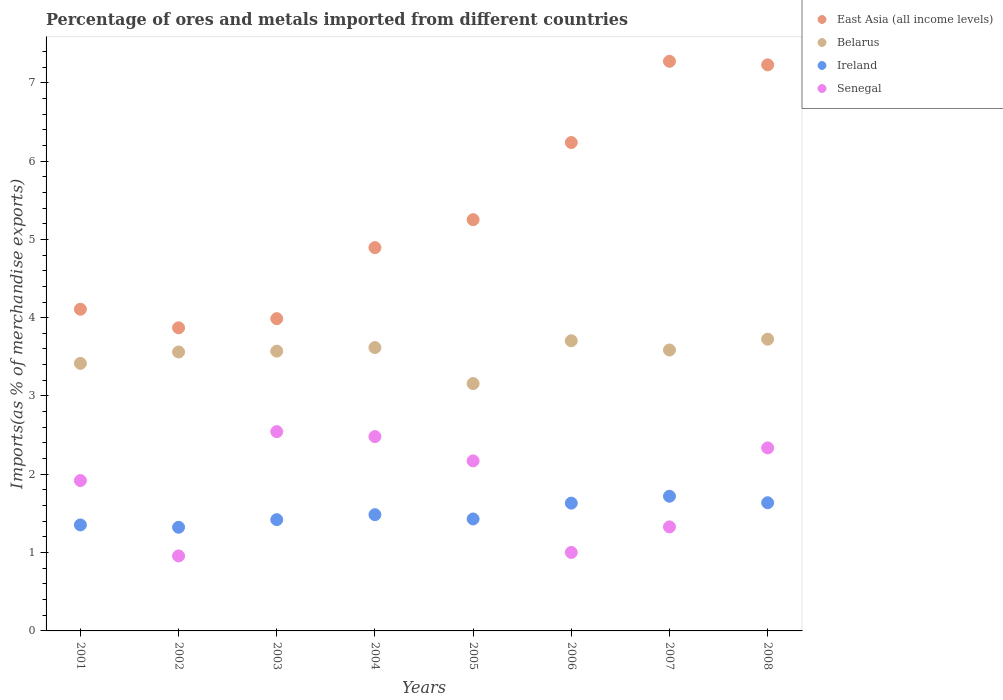How many different coloured dotlines are there?
Ensure brevity in your answer.  4. Is the number of dotlines equal to the number of legend labels?
Offer a very short reply. Yes. What is the percentage of imports to different countries in Senegal in 2007?
Your answer should be compact. 1.33. Across all years, what is the maximum percentage of imports to different countries in Ireland?
Your response must be concise. 1.72. Across all years, what is the minimum percentage of imports to different countries in Senegal?
Make the answer very short. 0.96. In which year was the percentage of imports to different countries in East Asia (all income levels) maximum?
Provide a succinct answer. 2007. What is the total percentage of imports to different countries in East Asia (all income levels) in the graph?
Offer a very short reply. 42.85. What is the difference between the percentage of imports to different countries in Ireland in 2001 and that in 2004?
Give a very brief answer. -0.13. What is the difference between the percentage of imports to different countries in Belarus in 2007 and the percentage of imports to different countries in East Asia (all income levels) in 2008?
Provide a short and direct response. -3.64. What is the average percentage of imports to different countries in Belarus per year?
Give a very brief answer. 3.54. In the year 2006, what is the difference between the percentage of imports to different countries in Ireland and percentage of imports to different countries in Belarus?
Provide a short and direct response. -2.07. What is the ratio of the percentage of imports to different countries in Senegal in 2004 to that in 2008?
Your answer should be compact. 1.06. What is the difference between the highest and the second highest percentage of imports to different countries in Ireland?
Your answer should be compact. 0.08. What is the difference between the highest and the lowest percentage of imports to different countries in Belarus?
Your answer should be compact. 0.57. In how many years, is the percentage of imports to different countries in Senegal greater than the average percentage of imports to different countries in Senegal taken over all years?
Your answer should be very brief. 5. Is it the case that in every year, the sum of the percentage of imports to different countries in East Asia (all income levels) and percentage of imports to different countries in Senegal  is greater than the sum of percentage of imports to different countries in Belarus and percentage of imports to different countries in Ireland?
Keep it short and to the point. No. Does the percentage of imports to different countries in Ireland monotonically increase over the years?
Provide a succinct answer. No. How many years are there in the graph?
Your answer should be very brief. 8. What is the difference between two consecutive major ticks on the Y-axis?
Provide a succinct answer. 1. Are the values on the major ticks of Y-axis written in scientific E-notation?
Your response must be concise. No. Does the graph contain grids?
Keep it short and to the point. No. How many legend labels are there?
Make the answer very short. 4. How are the legend labels stacked?
Your answer should be very brief. Vertical. What is the title of the graph?
Provide a short and direct response. Percentage of ores and metals imported from different countries. What is the label or title of the Y-axis?
Your answer should be compact. Imports(as % of merchandise exports). What is the Imports(as % of merchandise exports) of East Asia (all income levels) in 2001?
Your answer should be compact. 4.11. What is the Imports(as % of merchandise exports) of Belarus in 2001?
Offer a terse response. 3.42. What is the Imports(as % of merchandise exports) of Ireland in 2001?
Keep it short and to the point. 1.35. What is the Imports(as % of merchandise exports) of Senegal in 2001?
Give a very brief answer. 1.92. What is the Imports(as % of merchandise exports) in East Asia (all income levels) in 2002?
Your answer should be compact. 3.87. What is the Imports(as % of merchandise exports) in Belarus in 2002?
Provide a short and direct response. 3.56. What is the Imports(as % of merchandise exports) of Ireland in 2002?
Provide a succinct answer. 1.32. What is the Imports(as % of merchandise exports) of Senegal in 2002?
Your response must be concise. 0.96. What is the Imports(as % of merchandise exports) of East Asia (all income levels) in 2003?
Keep it short and to the point. 3.99. What is the Imports(as % of merchandise exports) of Belarus in 2003?
Provide a short and direct response. 3.57. What is the Imports(as % of merchandise exports) of Ireland in 2003?
Provide a short and direct response. 1.42. What is the Imports(as % of merchandise exports) of Senegal in 2003?
Your answer should be very brief. 2.54. What is the Imports(as % of merchandise exports) of East Asia (all income levels) in 2004?
Your answer should be very brief. 4.89. What is the Imports(as % of merchandise exports) of Belarus in 2004?
Offer a terse response. 3.62. What is the Imports(as % of merchandise exports) in Ireland in 2004?
Offer a very short reply. 1.48. What is the Imports(as % of merchandise exports) in Senegal in 2004?
Provide a succinct answer. 2.48. What is the Imports(as % of merchandise exports) in East Asia (all income levels) in 2005?
Your answer should be compact. 5.25. What is the Imports(as % of merchandise exports) in Belarus in 2005?
Give a very brief answer. 3.16. What is the Imports(as % of merchandise exports) in Ireland in 2005?
Offer a very short reply. 1.43. What is the Imports(as % of merchandise exports) in Senegal in 2005?
Your answer should be compact. 2.17. What is the Imports(as % of merchandise exports) in East Asia (all income levels) in 2006?
Offer a very short reply. 6.24. What is the Imports(as % of merchandise exports) in Belarus in 2006?
Ensure brevity in your answer.  3.71. What is the Imports(as % of merchandise exports) of Ireland in 2006?
Ensure brevity in your answer.  1.63. What is the Imports(as % of merchandise exports) of Senegal in 2006?
Your answer should be compact. 1. What is the Imports(as % of merchandise exports) in East Asia (all income levels) in 2007?
Your response must be concise. 7.27. What is the Imports(as % of merchandise exports) in Belarus in 2007?
Provide a short and direct response. 3.59. What is the Imports(as % of merchandise exports) of Ireland in 2007?
Your answer should be very brief. 1.72. What is the Imports(as % of merchandise exports) of Senegal in 2007?
Ensure brevity in your answer.  1.33. What is the Imports(as % of merchandise exports) in East Asia (all income levels) in 2008?
Your response must be concise. 7.23. What is the Imports(as % of merchandise exports) of Belarus in 2008?
Make the answer very short. 3.73. What is the Imports(as % of merchandise exports) of Ireland in 2008?
Your answer should be very brief. 1.64. What is the Imports(as % of merchandise exports) of Senegal in 2008?
Provide a short and direct response. 2.34. Across all years, what is the maximum Imports(as % of merchandise exports) in East Asia (all income levels)?
Provide a succinct answer. 7.27. Across all years, what is the maximum Imports(as % of merchandise exports) of Belarus?
Give a very brief answer. 3.73. Across all years, what is the maximum Imports(as % of merchandise exports) in Ireland?
Give a very brief answer. 1.72. Across all years, what is the maximum Imports(as % of merchandise exports) in Senegal?
Ensure brevity in your answer.  2.54. Across all years, what is the minimum Imports(as % of merchandise exports) of East Asia (all income levels)?
Make the answer very short. 3.87. Across all years, what is the minimum Imports(as % of merchandise exports) in Belarus?
Offer a very short reply. 3.16. Across all years, what is the minimum Imports(as % of merchandise exports) in Ireland?
Provide a short and direct response. 1.32. Across all years, what is the minimum Imports(as % of merchandise exports) of Senegal?
Your answer should be compact. 0.96. What is the total Imports(as % of merchandise exports) in East Asia (all income levels) in the graph?
Ensure brevity in your answer.  42.85. What is the total Imports(as % of merchandise exports) of Belarus in the graph?
Keep it short and to the point. 28.34. What is the total Imports(as % of merchandise exports) in Ireland in the graph?
Offer a very short reply. 12. What is the total Imports(as % of merchandise exports) of Senegal in the graph?
Your response must be concise. 14.74. What is the difference between the Imports(as % of merchandise exports) of East Asia (all income levels) in 2001 and that in 2002?
Give a very brief answer. 0.24. What is the difference between the Imports(as % of merchandise exports) of Belarus in 2001 and that in 2002?
Give a very brief answer. -0.15. What is the difference between the Imports(as % of merchandise exports) of Ireland in 2001 and that in 2002?
Keep it short and to the point. 0.03. What is the difference between the Imports(as % of merchandise exports) in Senegal in 2001 and that in 2002?
Your answer should be very brief. 0.96. What is the difference between the Imports(as % of merchandise exports) in East Asia (all income levels) in 2001 and that in 2003?
Keep it short and to the point. 0.12. What is the difference between the Imports(as % of merchandise exports) in Belarus in 2001 and that in 2003?
Offer a terse response. -0.16. What is the difference between the Imports(as % of merchandise exports) of Ireland in 2001 and that in 2003?
Provide a short and direct response. -0.07. What is the difference between the Imports(as % of merchandise exports) of Senegal in 2001 and that in 2003?
Offer a terse response. -0.62. What is the difference between the Imports(as % of merchandise exports) in East Asia (all income levels) in 2001 and that in 2004?
Offer a terse response. -0.79. What is the difference between the Imports(as % of merchandise exports) in Belarus in 2001 and that in 2004?
Give a very brief answer. -0.2. What is the difference between the Imports(as % of merchandise exports) in Ireland in 2001 and that in 2004?
Your answer should be compact. -0.13. What is the difference between the Imports(as % of merchandise exports) in Senegal in 2001 and that in 2004?
Keep it short and to the point. -0.56. What is the difference between the Imports(as % of merchandise exports) of East Asia (all income levels) in 2001 and that in 2005?
Keep it short and to the point. -1.14. What is the difference between the Imports(as % of merchandise exports) of Belarus in 2001 and that in 2005?
Your answer should be compact. 0.26. What is the difference between the Imports(as % of merchandise exports) in Ireland in 2001 and that in 2005?
Provide a succinct answer. -0.08. What is the difference between the Imports(as % of merchandise exports) of Senegal in 2001 and that in 2005?
Ensure brevity in your answer.  -0.25. What is the difference between the Imports(as % of merchandise exports) in East Asia (all income levels) in 2001 and that in 2006?
Make the answer very short. -2.13. What is the difference between the Imports(as % of merchandise exports) of Belarus in 2001 and that in 2006?
Ensure brevity in your answer.  -0.29. What is the difference between the Imports(as % of merchandise exports) of Ireland in 2001 and that in 2006?
Make the answer very short. -0.28. What is the difference between the Imports(as % of merchandise exports) in Senegal in 2001 and that in 2006?
Ensure brevity in your answer.  0.92. What is the difference between the Imports(as % of merchandise exports) of East Asia (all income levels) in 2001 and that in 2007?
Keep it short and to the point. -3.17. What is the difference between the Imports(as % of merchandise exports) of Belarus in 2001 and that in 2007?
Keep it short and to the point. -0.17. What is the difference between the Imports(as % of merchandise exports) of Ireland in 2001 and that in 2007?
Keep it short and to the point. -0.37. What is the difference between the Imports(as % of merchandise exports) in Senegal in 2001 and that in 2007?
Your response must be concise. 0.59. What is the difference between the Imports(as % of merchandise exports) in East Asia (all income levels) in 2001 and that in 2008?
Provide a short and direct response. -3.12. What is the difference between the Imports(as % of merchandise exports) in Belarus in 2001 and that in 2008?
Provide a succinct answer. -0.31. What is the difference between the Imports(as % of merchandise exports) in Ireland in 2001 and that in 2008?
Your response must be concise. -0.28. What is the difference between the Imports(as % of merchandise exports) in Senegal in 2001 and that in 2008?
Provide a succinct answer. -0.42. What is the difference between the Imports(as % of merchandise exports) of East Asia (all income levels) in 2002 and that in 2003?
Make the answer very short. -0.12. What is the difference between the Imports(as % of merchandise exports) in Belarus in 2002 and that in 2003?
Offer a very short reply. -0.01. What is the difference between the Imports(as % of merchandise exports) of Ireland in 2002 and that in 2003?
Provide a short and direct response. -0.1. What is the difference between the Imports(as % of merchandise exports) of Senegal in 2002 and that in 2003?
Offer a terse response. -1.59. What is the difference between the Imports(as % of merchandise exports) of East Asia (all income levels) in 2002 and that in 2004?
Your answer should be compact. -1.02. What is the difference between the Imports(as % of merchandise exports) in Belarus in 2002 and that in 2004?
Provide a succinct answer. -0.06. What is the difference between the Imports(as % of merchandise exports) in Ireland in 2002 and that in 2004?
Your response must be concise. -0.16. What is the difference between the Imports(as % of merchandise exports) of Senegal in 2002 and that in 2004?
Your answer should be very brief. -1.52. What is the difference between the Imports(as % of merchandise exports) of East Asia (all income levels) in 2002 and that in 2005?
Your answer should be compact. -1.38. What is the difference between the Imports(as % of merchandise exports) of Belarus in 2002 and that in 2005?
Provide a short and direct response. 0.4. What is the difference between the Imports(as % of merchandise exports) of Ireland in 2002 and that in 2005?
Your answer should be very brief. -0.11. What is the difference between the Imports(as % of merchandise exports) in Senegal in 2002 and that in 2005?
Provide a short and direct response. -1.21. What is the difference between the Imports(as % of merchandise exports) in East Asia (all income levels) in 2002 and that in 2006?
Offer a very short reply. -2.37. What is the difference between the Imports(as % of merchandise exports) in Belarus in 2002 and that in 2006?
Provide a succinct answer. -0.14. What is the difference between the Imports(as % of merchandise exports) in Ireland in 2002 and that in 2006?
Your answer should be very brief. -0.31. What is the difference between the Imports(as % of merchandise exports) of Senegal in 2002 and that in 2006?
Offer a very short reply. -0.04. What is the difference between the Imports(as % of merchandise exports) in East Asia (all income levels) in 2002 and that in 2007?
Offer a terse response. -3.4. What is the difference between the Imports(as % of merchandise exports) of Belarus in 2002 and that in 2007?
Your answer should be very brief. -0.03. What is the difference between the Imports(as % of merchandise exports) of Ireland in 2002 and that in 2007?
Offer a terse response. -0.4. What is the difference between the Imports(as % of merchandise exports) of Senegal in 2002 and that in 2007?
Keep it short and to the point. -0.37. What is the difference between the Imports(as % of merchandise exports) in East Asia (all income levels) in 2002 and that in 2008?
Offer a very short reply. -3.36. What is the difference between the Imports(as % of merchandise exports) in Belarus in 2002 and that in 2008?
Provide a succinct answer. -0.16. What is the difference between the Imports(as % of merchandise exports) in Ireland in 2002 and that in 2008?
Provide a short and direct response. -0.31. What is the difference between the Imports(as % of merchandise exports) in Senegal in 2002 and that in 2008?
Offer a terse response. -1.38. What is the difference between the Imports(as % of merchandise exports) of East Asia (all income levels) in 2003 and that in 2004?
Offer a very short reply. -0.91. What is the difference between the Imports(as % of merchandise exports) in Belarus in 2003 and that in 2004?
Offer a very short reply. -0.05. What is the difference between the Imports(as % of merchandise exports) of Ireland in 2003 and that in 2004?
Make the answer very short. -0.06. What is the difference between the Imports(as % of merchandise exports) in Senegal in 2003 and that in 2004?
Ensure brevity in your answer.  0.06. What is the difference between the Imports(as % of merchandise exports) of East Asia (all income levels) in 2003 and that in 2005?
Make the answer very short. -1.26. What is the difference between the Imports(as % of merchandise exports) in Belarus in 2003 and that in 2005?
Provide a short and direct response. 0.41. What is the difference between the Imports(as % of merchandise exports) in Ireland in 2003 and that in 2005?
Your answer should be very brief. -0.01. What is the difference between the Imports(as % of merchandise exports) in Senegal in 2003 and that in 2005?
Provide a short and direct response. 0.37. What is the difference between the Imports(as % of merchandise exports) of East Asia (all income levels) in 2003 and that in 2006?
Provide a short and direct response. -2.25. What is the difference between the Imports(as % of merchandise exports) in Belarus in 2003 and that in 2006?
Offer a terse response. -0.13. What is the difference between the Imports(as % of merchandise exports) of Ireland in 2003 and that in 2006?
Your answer should be compact. -0.21. What is the difference between the Imports(as % of merchandise exports) in Senegal in 2003 and that in 2006?
Keep it short and to the point. 1.54. What is the difference between the Imports(as % of merchandise exports) of East Asia (all income levels) in 2003 and that in 2007?
Your answer should be compact. -3.29. What is the difference between the Imports(as % of merchandise exports) of Belarus in 2003 and that in 2007?
Provide a short and direct response. -0.01. What is the difference between the Imports(as % of merchandise exports) of Ireland in 2003 and that in 2007?
Provide a short and direct response. -0.3. What is the difference between the Imports(as % of merchandise exports) in Senegal in 2003 and that in 2007?
Ensure brevity in your answer.  1.22. What is the difference between the Imports(as % of merchandise exports) in East Asia (all income levels) in 2003 and that in 2008?
Offer a terse response. -3.24. What is the difference between the Imports(as % of merchandise exports) of Belarus in 2003 and that in 2008?
Offer a very short reply. -0.15. What is the difference between the Imports(as % of merchandise exports) in Ireland in 2003 and that in 2008?
Your answer should be compact. -0.22. What is the difference between the Imports(as % of merchandise exports) of Senegal in 2003 and that in 2008?
Make the answer very short. 0.21. What is the difference between the Imports(as % of merchandise exports) of East Asia (all income levels) in 2004 and that in 2005?
Give a very brief answer. -0.36. What is the difference between the Imports(as % of merchandise exports) in Belarus in 2004 and that in 2005?
Provide a short and direct response. 0.46. What is the difference between the Imports(as % of merchandise exports) of Ireland in 2004 and that in 2005?
Keep it short and to the point. 0.05. What is the difference between the Imports(as % of merchandise exports) of Senegal in 2004 and that in 2005?
Offer a very short reply. 0.31. What is the difference between the Imports(as % of merchandise exports) in East Asia (all income levels) in 2004 and that in 2006?
Offer a very short reply. -1.34. What is the difference between the Imports(as % of merchandise exports) in Belarus in 2004 and that in 2006?
Your response must be concise. -0.09. What is the difference between the Imports(as % of merchandise exports) in Ireland in 2004 and that in 2006?
Your response must be concise. -0.15. What is the difference between the Imports(as % of merchandise exports) of Senegal in 2004 and that in 2006?
Make the answer very short. 1.48. What is the difference between the Imports(as % of merchandise exports) in East Asia (all income levels) in 2004 and that in 2007?
Keep it short and to the point. -2.38. What is the difference between the Imports(as % of merchandise exports) in Belarus in 2004 and that in 2007?
Give a very brief answer. 0.03. What is the difference between the Imports(as % of merchandise exports) of Ireland in 2004 and that in 2007?
Provide a succinct answer. -0.24. What is the difference between the Imports(as % of merchandise exports) in Senegal in 2004 and that in 2007?
Make the answer very short. 1.15. What is the difference between the Imports(as % of merchandise exports) in East Asia (all income levels) in 2004 and that in 2008?
Make the answer very short. -2.33. What is the difference between the Imports(as % of merchandise exports) of Belarus in 2004 and that in 2008?
Provide a succinct answer. -0.11. What is the difference between the Imports(as % of merchandise exports) of Ireland in 2004 and that in 2008?
Your response must be concise. -0.15. What is the difference between the Imports(as % of merchandise exports) of Senegal in 2004 and that in 2008?
Offer a very short reply. 0.14. What is the difference between the Imports(as % of merchandise exports) of East Asia (all income levels) in 2005 and that in 2006?
Provide a short and direct response. -0.99. What is the difference between the Imports(as % of merchandise exports) of Belarus in 2005 and that in 2006?
Ensure brevity in your answer.  -0.55. What is the difference between the Imports(as % of merchandise exports) in Ireland in 2005 and that in 2006?
Your response must be concise. -0.2. What is the difference between the Imports(as % of merchandise exports) in Senegal in 2005 and that in 2006?
Keep it short and to the point. 1.17. What is the difference between the Imports(as % of merchandise exports) of East Asia (all income levels) in 2005 and that in 2007?
Provide a short and direct response. -2.02. What is the difference between the Imports(as % of merchandise exports) of Belarus in 2005 and that in 2007?
Give a very brief answer. -0.43. What is the difference between the Imports(as % of merchandise exports) in Ireland in 2005 and that in 2007?
Keep it short and to the point. -0.29. What is the difference between the Imports(as % of merchandise exports) of Senegal in 2005 and that in 2007?
Ensure brevity in your answer.  0.84. What is the difference between the Imports(as % of merchandise exports) in East Asia (all income levels) in 2005 and that in 2008?
Keep it short and to the point. -1.98. What is the difference between the Imports(as % of merchandise exports) of Belarus in 2005 and that in 2008?
Make the answer very short. -0.57. What is the difference between the Imports(as % of merchandise exports) in Ireland in 2005 and that in 2008?
Offer a terse response. -0.21. What is the difference between the Imports(as % of merchandise exports) in Senegal in 2005 and that in 2008?
Provide a succinct answer. -0.17. What is the difference between the Imports(as % of merchandise exports) of East Asia (all income levels) in 2006 and that in 2007?
Ensure brevity in your answer.  -1.04. What is the difference between the Imports(as % of merchandise exports) of Belarus in 2006 and that in 2007?
Ensure brevity in your answer.  0.12. What is the difference between the Imports(as % of merchandise exports) of Ireland in 2006 and that in 2007?
Ensure brevity in your answer.  -0.09. What is the difference between the Imports(as % of merchandise exports) of Senegal in 2006 and that in 2007?
Your response must be concise. -0.33. What is the difference between the Imports(as % of merchandise exports) of East Asia (all income levels) in 2006 and that in 2008?
Give a very brief answer. -0.99. What is the difference between the Imports(as % of merchandise exports) of Belarus in 2006 and that in 2008?
Your response must be concise. -0.02. What is the difference between the Imports(as % of merchandise exports) of Ireland in 2006 and that in 2008?
Your answer should be compact. -0.01. What is the difference between the Imports(as % of merchandise exports) of Senegal in 2006 and that in 2008?
Make the answer very short. -1.33. What is the difference between the Imports(as % of merchandise exports) in East Asia (all income levels) in 2007 and that in 2008?
Your answer should be compact. 0.05. What is the difference between the Imports(as % of merchandise exports) of Belarus in 2007 and that in 2008?
Offer a terse response. -0.14. What is the difference between the Imports(as % of merchandise exports) in Ireland in 2007 and that in 2008?
Provide a succinct answer. 0.08. What is the difference between the Imports(as % of merchandise exports) of Senegal in 2007 and that in 2008?
Ensure brevity in your answer.  -1.01. What is the difference between the Imports(as % of merchandise exports) in East Asia (all income levels) in 2001 and the Imports(as % of merchandise exports) in Belarus in 2002?
Provide a short and direct response. 0.55. What is the difference between the Imports(as % of merchandise exports) of East Asia (all income levels) in 2001 and the Imports(as % of merchandise exports) of Ireland in 2002?
Provide a succinct answer. 2.78. What is the difference between the Imports(as % of merchandise exports) of East Asia (all income levels) in 2001 and the Imports(as % of merchandise exports) of Senegal in 2002?
Make the answer very short. 3.15. What is the difference between the Imports(as % of merchandise exports) in Belarus in 2001 and the Imports(as % of merchandise exports) in Ireland in 2002?
Offer a very short reply. 2.09. What is the difference between the Imports(as % of merchandise exports) in Belarus in 2001 and the Imports(as % of merchandise exports) in Senegal in 2002?
Ensure brevity in your answer.  2.46. What is the difference between the Imports(as % of merchandise exports) of Ireland in 2001 and the Imports(as % of merchandise exports) of Senegal in 2002?
Make the answer very short. 0.4. What is the difference between the Imports(as % of merchandise exports) in East Asia (all income levels) in 2001 and the Imports(as % of merchandise exports) in Belarus in 2003?
Ensure brevity in your answer.  0.54. What is the difference between the Imports(as % of merchandise exports) in East Asia (all income levels) in 2001 and the Imports(as % of merchandise exports) in Ireland in 2003?
Your answer should be very brief. 2.69. What is the difference between the Imports(as % of merchandise exports) in East Asia (all income levels) in 2001 and the Imports(as % of merchandise exports) in Senegal in 2003?
Your answer should be compact. 1.56. What is the difference between the Imports(as % of merchandise exports) in Belarus in 2001 and the Imports(as % of merchandise exports) in Ireland in 2003?
Your answer should be very brief. 2. What is the difference between the Imports(as % of merchandise exports) of Belarus in 2001 and the Imports(as % of merchandise exports) of Senegal in 2003?
Your response must be concise. 0.87. What is the difference between the Imports(as % of merchandise exports) of Ireland in 2001 and the Imports(as % of merchandise exports) of Senegal in 2003?
Ensure brevity in your answer.  -1.19. What is the difference between the Imports(as % of merchandise exports) in East Asia (all income levels) in 2001 and the Imports(as % of merchandise exports) in Belarus in 2004?
Your response must be concise. 0.49. What is the difference between the Imports(as % of merchandise exports) in East Asia (all income levels) in 2001 and the Imports(as % of merchandise exports) in Ireland in 2004?
Make the answer very short. 2.62. What is the difference between the Imports(as % of merchandise exports) of East Asia (all income levels) in 2001 and the Imports(as % of merchandise exports) of Senegal in 2004?
Your answer should be compact. 1.63. What is the difference between the Imports(as % of merchandise exports) of Belarus in 2001 and the Imports(as % of merchandise exports) of Ireland in 2004?
Provide a succinct answer. 1.93. What is the difference between the Imports(as % of merchandise exports) of Belarus in 2001 and the Imports(as % of merchandise exports) of Senegal in 2004?
Ensure brevity in your answer.  0.93. What is the difference between the Imports(as % of merchandise exports) of Ireland in 2001 and the Imports(as % of merchandise exports) of Senegal in 2004?
Your answer should be compact. -1.13. What is the difference between the Imports(as % of merchandise exports) in East Asia (all income levels) in 2001 and the Imports(as % of merchandise exports) in Belarus in 2005?
Offer a very short reply. 0.95. What is the difference between the Imports(as % of merchandise exports) of East Asia (all income levels) in 2001 and the Imports(as % of merchandise exports) of Ireland in 2005?
Ensure brevity in your answer.  2.68. What is the difference between the Imports(as % of merchandise exports) of East Asia (all income levels) in 2001 and the Imports(as % of merchandise exports) of Senegal in 2005?
Ensure brevity in your answer.  1.94. What is the difference between the Imports(as % of merchandise exports) of Belarus in 2001 and the Imports(as % of merchandise exports) of Ireland in 2005?
Offer a very short reply. 1.99. What is the difference between the Imports(as % of merchandise exports) of Belarus in 2001 and the Imports(as % of merchandise exports) of Senegal in 2005?
Make the answer very short. 1.25. What is the difference between the Imports(as % of merchandise exports) in Ireland in 2001 and the Imports(as % of merchandise exports) in Senegal in 2005?
Offer a very short reply. -0.82. What is the difference between the Imports(as % of merchandise exports) of East Asia (all income levels) in 2001 and the Imports(as % of merchandise exports) of Belarus in 2006?
Give a very brief answer. 0.4. What is the difference between the Imports(as % of merchandise exports) in East Asia (all income levels) in 2001 and the Imports(as % of merchandise exports) in Ireland in 2006?
Provide a short and direct response. 2.48. What is the difference between the Imports(as % of merchandise exports) in East Asia (all income levels) in 2001 and the Imports(as % of merchandise exports) in Senegal in 2006?
Your answer should be compact. 3.11. What is the difference between the Imports(as % of merchandise exports) of Belarus in 2001 and the Imports(as % of merchandise exports) of Ireland in 2006?
Your answer should be compact. 1.78. What is the difference between the Imports(as % of merchandise exports) of Belarus in 2001 and the Imports(as % of merchandise exports) of Senegal in 2006?
Ensure brevity in your answer.  2.41. What is the difference between the Imports(as % of merchandise exports) of Ireland in 2001 and the Imports(as % of merchandise exports) of Senegal in 2006?
Give a very brief answer. 0.35. What is the difference between the Imports(as % of merchandise exports) in East Asia (all income levels) in 2001 and the Imports(as % of merchandise exports) in Belarus in 2007?
Your response must be concise. 0.52. What is the difference between the Imports(as % of merchandise exports) of East Asia (all income levels) in 2001 and the Imports(as % of merchandise exports) of Ireland in 2007?
Offer a very short reply. 2.39. What is the difference between the Imports(as % of merchandise exports) in East Asia (all income levels) in 2001 and the Imports(as % of merchandise exports) in Senegal in 2007?
Give a very brief answer. 2.78. What is the difference between the Imports(as % of merchandise exports) in Belarus in 2001 and the Imports(as % of merchandise exports) in Ireland in 2007?
Offer a very short reply. 1.7. What is the difference between the Imports(as % of merchandise exports) in Belarus in 2001 and the Imports(as % of merchandise exports) in Senegal in 2007?
Provide a succinct answer. 2.09. What is the difference between the Imports(as % of merchandise exports) of Ireland in 2001 and the Imports(as % of merchandise exports) of Senegal in 2007?
Provide a short and direct response. 0.03. What is the difference between the Imports(as % of merchandise exports) in East Asia (all income levels) in 2001 and the Imports(as % of merchandise exports) in Belarus in 2008?
Provide a succinct answer. 0.38. What is the difference between the Imports(as % of merchandise exports) of East Asia (all income levels) in 2001 and the Imports(as % of merchandise exports) of Ireland in 2008?
Give a very brief answer. 2.47. What is the difference between the Imports(as % of merchandise exports) of East Asia (all income levels) in 2001 and the Imports(as % of merchandise exports) of Senegal in 2008?
Your response must be concise. 1.77. What is the difference between the Imports(as % of merchandise exports) in Belarus in 2001 and the Imports(as % of merchandise exports) in Ireland in 2008?
Your response must be concise. 1.78. What is the difference between the Imports(as % of merchandise exports) in Belarus in 2001 and the Imports(as % of merchandise exports) in Senegal in 2008?
Make the answer very short. 1.08. What is the difference between the Imports(as % of merchandise exports) in Ireland in 2001 and the Imports(as % of merchandise exports) in Senegal in 2008?
Give a very brief answer. -0.98. What is the difference between the Imports(as % of merchandise exports) of East Asia (all income levels) in 2002 and the Imports(as % of merchandise exports) of Belarus in 2003?
Give a very brief answer. 0.3. What is the difference between the Imports(as % of merchandise exports) of East Asia (all income levels) in 2002 and the Imports(as % of merchandise exports) of Ireland in 2003?
Your answer should be compact. 2.45. What is the difference between the Imports(as % of merchandise exports) of East Asia (all income levels) in 2002 and the Imports(as % of merchandise exports) of Senegal in 2003?
Keep it short and to the point. 1.33. What is the difference between the Imports(as % of merchandise exports) in Belarus in 2002 and the Imports(as % of merchandise exports) in Ireland in 2003?
Your answer should be compact. 2.14. What is the difference between the Imports(as % of merchandise exports) of Belarus in 2002 and the Imports(as % of merchandise exports) of Senegal in 2003?
Your answer should be compact. 1.02. What is the difference between the Imports(as % of merchandise exports) in Ireland in 2002 and the Imports(as % of merchandise exports) in Senegal in 2003?
Make the answer very short. -1.22. What is the difference between the Imports(as % of merchandise exports) of East Asia (all income levels) in 2002 and the Imports(as % of merchandise exports) of Belarus in 2004?
Give a very brief answer. 0.25. What is the difference between the Imports(as % of merchandise exports) of East Asia (all income levels) in 2002 and the Imports(as % of merchandise exports) of Ireland in 2004?
Make the answer very short. 2.39. What is the difference between the Imports(as % of merchandise exports) of East Asia (all income levels) in 2002 and the Imports(as % of merchandise exports) of Senegal in 2004?
Make the answer very short. 1.39. What is the difference between the Imports(as % of merchandise exports) of Belarus in 2002 and the Imports(as % of merchandise exports) of Ireland in 2004?
Ensure brevity in your answer.  2.08. What is the difference between the Imports(as % of merchandise exports) of Belarus in 2002 and the Imports(as % of merchandise exports) of Senegal in 2004?
Your answer should be compact. 1.08. What is the difference between the Imports(as % of merchandise exports) of Ireland in 2002 and the Imports(as % of merchandise exports) of Senegal in 2004?
Offer a very short reply. -1.16. What is the difference between the Imports(as % of merchandise exports) of East Asia (all income levels) in 2002 and the Imports(as % of merchandise exports) of Belarus in 2005?
Offer a very short reply. 0.71. What is the difference between the Imports(as % of merchandise exports) in East Asia (all income levels) in 2002 and the Imports(as % of merchandise exports) in Ireland in 2005?
Your answer should be compact. 2.44. What is the difference between the Imports(as % of merchandise exports) of East Asia (all income levels) in 2002 and the Imports(as % of merchandise exports) of Senegal in 2005?
Give a very brief answer. 1.7. What is the difference between the Imports(as % of merchandise exports) of Belarus in 2002 and the Imports(as % of merchandise exports) of Ireland in 2005?
Give a very brief answer. 2.13. What is the difference between the Imports(as % of merchandise exports) of Belarus in 2002 and the Imports(as % of merchandise exports) of Senegal in 2005?
Keep it short and to the point. 1.39. What is the difference between the Imports(as % of merchandise exports) in Ireland in 2002 and the Imports(as % of merchandise exports) in Senegal in 2005?
Your answer should be very brief. -0.85. What is the difference between the Imports(as % of merchandise exports) in East Asia (all income levels) in 2002 and the Imports(as % of merchandise exports) in Belarus in 2006?
Make the answer very short. 0.17. What is the difference between the Imports(as % of merchandise exports) in East Asia (all income levels) in 2002 and the Imports(as % of merchandise exports) in Ireland in 2006?
Your answer should be compact. 2.24. What is the difference between the Imports(as % of merchandise exports) of East Asia (all income levels) in 2002 and the Imports(as % of merchandise exports) of Senegal in 2006?
Your answer should be very brief. 2.87. What is the difference between the Imports(as % of merchandise exports) in Belarus in 2002 and the Imports(as % of merchandise exports) in Ireland in 2006?
Offer a terse response. 1.93. What is the difference between the Imports(as % of merchandise exports) of Belarus in 2002 and the Imports(as % of merchandise exports) of Senegal in 2006?
Give a very brief answer. 2.56. What is the difference between the Imports(as % of merchandise exports) of Ireland in 2002 and the Imports(as % of merchandise exports) of Senegal in 2006?
Provide a short and direct response. 0.32. What is the difference between the Imports(as % of merchandise exports) of East Asia (all income levels) in 2002 and the Imports(as % of merchandise exports) of Belarus in 2007?
Provide a succinct answer. 0.28. What is the difference between the Imports(as % of merchandise exports) in East Asia (all income levels) in 2002 and the Imports(as % of merchandise exports) in Ireland in 2007?
Ensure brevity in your answer.  2.15. What is the difference between the Imports(as % of merchandise exports) of East Asia (all income levels) in 2002 and the Imports(as % of merchandise exports) of Senegal in 2007?
Make the answer very short. 2.54. What is the difference between the Imports(as % of merchandise exports) in Belarus in 2002 and the Imports(as % of merchandise exports) in Ireland in 2007?
Ensure brevity in your answer.  1.84. What is the difference between the Imports(as % of merchandise exports) in Belarus in 2002 and the Imports(as % of merchandise exports) in Senegal in 2007?
Offer a terse response. 2.23. What is the difference between the Imports(as % of merchandise exports) of Ireland in 2002 and the Imports(as % of merchandise exports) of Senegal in 2007?
Offer a very short reply. -0. What is the difference between the Imports(as % of merchandise exports) in East Asia (all income levels) in 2002 and the Imports(as % of merchandise exports) in Belarus in 2008?
Ensure brevity in your answer.  0.15. What is the difference between the Imports(as % of merchandise exports) in East Asia (all income levels) in 2002 and the Imports(as % of merchandise exports) in Ireland in 2008?
Make the answer very short. 2.23. What is the difference between the Imports(as % of merchandise exports) of East Asia (all income levels) in 2002 and the Imports(as % of merchandise exports) of Senegal in 2008?
Make the answer very short. 1.53. What is the difference between the Imports(as % of merchandise exports) in Belarus in 2002 and the Imports(as % of merchandise exports) in Ireland in 2008?
Your answer should be compact. 1.92. What is the difference between the Imports(as % of merchandise exports) in Belarus in 2002 and the Imports(as % of merchandise exports) in Senegal in 2008?
Provide a short and direct response. 1.22. What is the difference between the Imports(as % of merchandise exports) in Ireland in 2002 and the Imports(as % of merchandise exports) in Senegal in 2008?
Offer a very short reply. -1.01. What is the difference between the Imports(as % of merchandise exports) of East Asia (all income levels) in 2003 and the Imports(as % of merchandise exports) of Belarus in 2004?
Your answer should be very brief. 0.37. What is the difference between the Imports(as % of merchandise exports) in East Asia (all income levels) in 2003 and the Imports(as % of merchandise exports) in Ireland in 2004?
Make the answer very short. 2.5. What is the difference between the Imports(as % of merchandise exports) in East Asia (all income levels) in 2003 and the Imports(as % of merchandise exports) in Senegal in 2004?
Your response must be concise. 1.51. What is the difference between the Imports(as % of merchandise exports) of Belarus in 2003 and the Imports(as % of merchandise exports) of Ireland in 2004?
Offer a very short reply. 2.09. What is the difference between the Imports(as % of merchandise exports) in Ireland in 2003 and the Imports(as % of merchandise exports) in Senegal in 2004?
Make the answer very short. -1.06. What is the difference between the Imports(as % of merchandise exports) of East Asia (all income levels) in 2003 and the Imports(as % of merchandise exports) of Belarus in 2005?
Give a very brief answer. 0.83. What is the difference between the Imports(as % of merchandise exports) in East Asia (all income levels) in 2003 and the Imports(as % of merchandise exports) in Ireland in 2005?
Give a very brief answer. 2.56. What is the difference between the Imports(as % of merchandise exports) in East Asia (all income levels) in 2003 and the Imports(as % of merchandise exports) in Senegal in 2005?
Your answer should be very brief. 1.82. What is the difference between the Imports(as % of merchandise exports) of Belarus in 2003 and the Imports(as % of merchandise exports) of Ireland in 2005?
Provide a succinct answer. 2.14. What is the difference between the Imports(as % of merchandise exports) of Belarus in 2003 and the Imports(as % of merchandise exports) of Senegal in 2005?
Make the answer very short. 1.4. What is the difference between the Imports(as % of merchandise exports) in Ireland in 2003 and the Imports(as % of merchandise exports) in Senegal in 2005?
Offer a very short reply. -0.75. What is the difference between the Imports(as % of merchandise exports) in East Asia (all income levels) in 2003 and the Imports(as % of merchandise exports) in Belarus in 2006?
Your response must be concise. 0.28. What is the difference between the Imports(as % of merchandise exports) in East Asia (all income levels) in 2003 and the Imports(as % of merchandise exports) in Ireland in 2006?
Provide a succinct answer. 2.36. What is the difference between the Imports(as % of merchandise exports) of East Asia (all income levels) in 2003 and the Imports(as % of merchandise exports) of Senegal in 2006?
Your answer should be compact. 2.99. What is the difference between the Imports(as % of merchandise exports) in Belarus in 2003 and the Imports(as % of merchandise exports) in Ireland in 2006?
Your answer should be very brief. 1.94. What is the difference between the Imports(as % of merchandise exports) of Belarus in 2003 and the Imports(as % of merchandise exports) of Senegal in 2006?
Give a very brief answer. 2.57. What is the difference between the Imports(as % of merchandise exports) in Ireland in 2003 and the Imports(as % of merchandise exports) in Senegal in 2006?
Give a very brief answer. 0.42. What is the difference between the Imports(as % of merchandise exports) of East Asia (all income levels) in 2003 and the Imports(as % of merchandise exports) of Belarus in 2007?
Make the answer very short. 0.4. What is the difference between the Imports(as % of merchandise exports) in East Asia (all income levels) in 2003 and the Imports(as % of merchandise exports) in Ireland in 2007?
Your answer should be compact. 2.27. What is the difference between the Imports(as % of merchandise exports) in East Asia (all income levels) in 2003 and the Imports(as % of merchandise exports) in Senegal in 2007?
Give a very brief answer. 2.66. What is the difference between the Imports(as % of merchandise exports) in Belarus in 2003 and the Imports(as % of merchandise exports) in Ireland in 2007?
Provide a short and direct response. 1.85. What is the difference between the Imports(as % of merchandise exports) of Belarus in 2003 and the Imports(as % of merchandise exports) of Senegal in 2007?
Make the answer very short. 2.24. What is the difference between the Imports(as % of merchandise exports) in Ireland in 2003 and the Imports(as % of merchandise exports) in Senegal in 2007?
Provide a succinct answer. 0.09. What is the difference between the Imports(as % of merchandise exports) of East Asia (all income levels) in 2003 and the Imports(as % of merchandise exports) of Belarus in 2008?
Your answer should be very brief. 0.26. What is the difference between the Imports(as % of merchandise exports) in East Asia (all income levels) in 2003 and the Imports(as % of merchandise exports) in Ireland in 2008?
Make the answer very short. 2.35. What is the difference between the Imports(as % of merchandise exports) in East Asia (all income levels) in 2003 and the Imports(as % of merchandise exports) in Senegal in 2008?
Your answer should be very brief. 1.65. What is the difference between the Imports(as % of merchandise exports) of Belarus in 2003 and the Imports(as % of merchandise exports) of Ireland in 2008?
Provide a short and direct response. 1.94. What is the difference between the Imports(as % of merchandise exports) in Belarus in 2003 and the Imports(as % of merchandise exports) in Senegal in 2008?
Give a very brief answer. 1.24. What is the difference between the Imports(as % of merchandise exports) in Ireland in 2003 and the Imports(as % of merchandise exports) in Senegal in 2008?
Your answer should be very brief. -0.92. What is the difference between the Imports(as % of merchandise exports) of East Asia (all income levels) in 2004 and the Imports(as % of merchandise exports) of Belarus in 2005?
Your answer should be compact. 1.74. What is the difference between the Imports(as % of merchandise exports) of East Asia (all income levels) in 2004 and the Imports(as % of merchandise exports) of Ireland in 2005?
Ensure brevity in your answer.  3.47. What is the difference between the Imports(as % of merchandise exports) of East Asia (all income levels) in 2004 and the Imports(as % of merchandise exports) of Senegal in 2005?
Offer a very short reply. 2.72. What is the difference between the Imports(as % of merchandise exports) in Belarus in 2004 and the Imports(as % of merchandise exports) in Ireland in 2005?
Offer a terse response. 2.19. What is the difference between the Imports(as % of merchandise exports) in Belarus in 2004 and the Imports(as % of merchandise exports) in Senegal in 2005?
Your answer should be very brief. 1.45. What is the difference between the Imports(as % of merchandise exports) of Ireland in 2004 and the Imports(as % of merchandise exports) of Senegal in 2005?
Offer a terse response. -0.69. What is the difference between the Imports(as % of merchandise exports) in East Asia (all income levels) in 2004 and the Imports(as % of merchandise exports) in Belarus in 2006?
Your answer should be very brief. 1.19. What is the difference between the Imports(as % of merchandise exports) in East Asia (all income levels) in 2004 and the Imports(as % of merchandise exports) in Ireland in 2006?
Your response must be concise. 3.26. What is the difference between the Imports(as % of merchandise exports) of East Asia (all income levels) in 2004 and the Imports(as % of merchandise exports) of Senegal in 2006?
Provide a succinct answer. 3.89. What is the difference between the Imports(as % of merchandise exports) in Belarus in 2004 and the Imports(as % of merchandise exports) in Ireland in 2006?
Offer a very short reply. 1.99. What is the difference between the Imports(as % of merchandise exports) of Belarus in 2004 and the Imports(as % of merchandise exports) of Senegal in 2006?
Offer a terse response. 2.62. What is the difference between the Imports(as % of merchandise exports) of Ireland in 2004 and the Imports(as % of merchandise exports) of Senegal in 2006?
Make the answer very short. 0.48. What is the difference between the Imports(as % of merchandise exports) in East Asia (all income levels) in 2004 and the Imports(as % of merchandise exports) in Belarus in 2007?
Provide a short and direct response. 1.31. What is the difference between the Imports(as % of merchandise exports) of East Asia (all income levels) in 2004 and the Imports(as % of merchandise exports) of Ireland in 2007?
Ensure brevity in your answer.  3.17. What is the difference between the Imports(as % of merchandise exports) of East Asia (all income levels) in 2004 and the Imports(as % of merchandise exports) of Senegal in 2007?
Offer a terse response. 3.57. What is the difference between the Imports(as % of merchandise exports) of Belarus in 2004 and the Imports(as % of merchandise exports) of Ireland in 2007?
Ensure brevity in your answer.  1.9. What is the difference between the Imports(as % of merchandise exports) of Belarus in 2004 and the Imports(as % of merchandise exports) of Senegal in 2007?
Keep it short and to the point. 2.29. What is the difference between the Imports(as % of merchandise exports) of Ireland in 2004 and the Imports(as % of merchandise exports) of Senegal in 2007?
Keep it short and to the point. 0.16. What is the difference between the Imports(as % of merchandise exports) in East Asia (all income levels) in 2004 and the Imports(as % of merchandise exports) in Belarus in 2008?
Your answer should be compact. 1.17. What is the difference between the Imports(as % of merchandise exports) of East Asia (all income levels) in 2004 and the Imports(as % of merchandise exports) of Ireland in 2008?
Make the answer very short. 3.26. What is the difference between the Imports(as % of merchandise exports) in East Asia (all income levels) in 2004 and the Imports(as % of merchandise exports) in Senegal in 2008?
Ensure brevity in your answer.  2.56. What is the difference between the Imports(as % of merchandise exports) in Belarus in 2004 and the Imports(as % of merchandise exports) in Ireland in 2008?
Your answer should be very brief. 1.98. What is the difference between the Imports(as % of merchandise exports) in Belarus in 2004 and the Imports(as % of merchandise exports) in Senegal in 2008?
Provide a succinct answer. 1.28. What is the difference between the Imports(as % of merchandise exports) in Ireland in 2004 and the Imports(as % of merchandise exports) in Senegal in 2008?
Provide a short and direct response. -0.85. What is the difference between the Imports(as % of merchandise exports) of East Asia (all income levels) in 2005 and the Imports(as % of merchandise exports) of Belarus in 2006?
Your answer should be compact. 1.55. What is the difference between the Imports(as % of merchandise exports) in East Asia (all income levels) in 2005 and the Imports(as % of merchandise exports) in Ireland in 2006?
Your response must be concise. 3.62. What is the difference between the Imports(as % of merchandise exports) of East Asia (all income levels) in 2005 and the Imports(as % of merchandise exports) of Senegal in 2006?
Provide a succinct answer. 4.25. What is the difference between the Imports(as % of merchandise exports) of Belarus in 2005 and the Imports(as % of merchandise exports) of Ireland in 2006?
Make the answer very short. 1.53. What is the difference between the Imports(as % of merchandise exports) of Belarus in 2005 and the Imports(as % of merchandise exports) of Senegal in 2006?
Ensure brevity in your answer.  2.16. What is the difference between the Imports(as % of merchandise exports) of Ireland in 2005 and the Imports(as % of merchandise exports) of Senegal in 2006?
Make the answer very short. 0.43. What is the difference between the Imports(as % of merchandise exports) in East Asia (all income levels) in 2005 and the Imports(as % of merchandise exports) in Belarus in 2007?
Your answer should be very brief. 1.66. What is the difference between the Imports(as % of merchandise exports) in East Asia (all income levels) in 2005 and the Imports(as % of merchandise exports) in Ireland in 2007?
Keep it short and to the point. 3.53. What is the difference between the Imports(as % of merchandise exports) of East Asia (all income levels) in 2005 and the Imports(as % of merchandise exports) of Senegal in 2007?
Make the answer very short. 3.92. What is the difference between the Imports(as % of merchandise exports) in Belarus in 2005 and the Imports(as % of merchandise exports) in Ireland in 2007?
Your answer should be compact. 1.44. What is the difference between the Imports(as % of merchandise exports) in Belarus in 2005 and the Imports(as % of merchandise exports) in Senegal in 2007?
Offer a very short reply. 1.83. What is the difference between the Imports(as % of merchandise exports) in Ireland in 2005 and the Imports(as % of merchandise exports) in Senegal in 2007?
Provide a short and direct response. 0.1. What is the difference between the Imports(as % of merchandise exports) of East Asia (all income levels) in 2005 and the Imports(as % of merchandise exports) of Belarus in 2008?
Make the answer very short. 1.53. What is the difference between the Imports(as % of merchandise exports) of East Asia (all income levels) in 2005 and the Imports(as % of merchandise exports) of Ireland in 2008?
Keep it short and to the point. 3.61. What is the difference between the Imports(as % of merchandise exports) of East Asia (all income levels) in 2005 and the Imports(as % of merchandise exports) of Senegal in 2008?
Give a very brief answer. 2.91. What is the difference between the Imports(as % of merchandise exports) of Belarus in 2005 and the Imports(as % of merchandise exports) of Ireland in 2008?
Give a very brief answer. 1.52. What is the difference between the Imports(as % of merchandise exports) of Belarus in 2005 and the Imports(as % of merchandise exports) of Senegal in 2008?
Keep it short and to the point. 0.82. What is the difference between the Imports(as % of merchandise exports) in Ireland in 2005 and the Imports(as % of merchandise exports) in Senegal in 2008?
Make the answer very short. -0.91. What is the difference between the Imports(as % of merchandise exports) in East Asia (all income levels) in 2006 and the Imports(as % of merchandise exports) in Belarus in 2007?
Keep it short and to the point. 2.65. What is the difference between the Imports(as % of merchandise exports) in East Asia (all income levels) in 2006 and the Imports(as % of merchandise exports) in Ireland in 2007?
Your answer should be very brief. 4.52. What is the difference between the Imports(as % of merchandise exports) in East Asia (all income levels) in 2006 and the Imports(as % of merchandise exports) in Senegal in 2007?
Provide a short and direct response. 4.91. What is the difference between the Imports(as % of merchandise exports) of Belarus in 2006 and the Imports(as % of merchandise exports) of Ireland in 2007?
Provide a short and direct response. 1.99. What is the difference between the Imports(as % of merchandise exports) in Belarus in 2006 and the Imports(as % of merchandise exports) in Senegal in 2007?
Provide a short and direct response. 2.38. What is the difference between the Imports(as % of merchandise exports) in Ireland in 2006 and the Imports(as % of merchandise exports) in Senegal in 2007?
Provide a succinct answer. 0.3. What is the difference between the Imports(as % of merchandise exports) of East Asia (all income levels) in 2006 and the Imports(as % of merchandise exports) of Belarus in 2008?
Your answer should be compact. 2.51. What is the difference between the Imports(as % of merchandise exports) of East Asia (all income levels) in 2006 and the Imports(as % of merchandise exports) of Ireland in 2008?
Provide a succinct answer. 4.6. What is the difference between the Imports(as % of merchandise exports) of East Asia (all income levels) in 2006 and the Imports(as % of merchandise exports) of Senegal in 2008?
Make the answer very short. 3.9. What is the difference between the Imports(as % of merchandise exports) in Belarus in 2006 and the Imports(as % of merchandise exports) in Ireland in 2008?
Keep it short and to the point. 2.07. What is the difference between the Imports(as % of merchandise exports) of Belarus in 2006 and the Imports(as % of merchandise exports) of Senegal in 2008?
Give a very brief answer. 1.37. What is the difference between the Imports(as % of merchandise exports) of Ireland in 2006 and the Imports(as % of merchandise exports) of Senegal in 2008?
Provide a succinct answer. -0.71. What is the difference between the Imports(as % of merchandise exports) in East Asia (all income levels) in 2007 and the Imports(as % of merchandise exports) in Belarus in 2008?
Keep it short and to the point. 3.55. What is the difference between the Imports(as % of merchandise exports) in East Asia (all income levels) in 2007 and the Imports(as % of merchandise exports) in Ireland in 2008?
Your response must be concise. 5.64. What is the difference between the Imports(as % of merchandise exports) of East Asia (all income levels) in 2007 and the Imports(as % of merchandise exports) of Senegal in 2008?
Provide a short and direct response. 4.94. What is the difference between the Imports(as % of merchandise exports) in Belarus in 2007 and the Imports(as % of merchandise exports) in Ireland in 2008?
Provide a short and direct response. 1.95. What is the difference between the Imports(as % of merchandise exports) in Ireland in 2007 and the Imports(as % of merchandise exports) in Senegal in 2008?
Ensure brevity in your answer.  -0.62. What is the average Imports(as % of merchandise exports) in East Asia (all income levels) per year?
Provide a succinct answer. 5.36. What is the average Imports(as % of merchandise exports) in Belarus per year?
Offer a very short reply. 3.54. What is the average Imports(as % of merchandise exports) of Ireland per year?
Your response must be concise. 1.5. What is the average Imports(as % of merchandise exports) in Senegal per year?
Give a very brief answer. 1.84. In the year 2001, what is the difference between the Imports(as % of merchandise exports) in East Asia (all income levels) and Imports(as % of merchandise exports) in Belarus?
Offer a terse response. 0.69. In the year 2001, what is the difference between the Imports(as % of merchandise exports) of East Asia (all income levels) and Imports(as % of merchandise exports) of Ireland?
Provide a succinct answer. 2.75. In the year 2001, what is the difference between the Imports(as % of merchandise exports) of East Asia (all income levels) and Imports(as % of merchandise exports) of Senegal?
Offer a terse response. 2.19. In the year 2001, what is the difference between the Imports(as % of merchandise exports) in Belarus and Imports(as % of merchandise exports) in Ireland?
Give a very brief answer. 2.06. In the year 2001, what is the difference between the Imports(as % of merchandise exports) in Belarus and Imports(as % of merchandise exports) in Senegal?
Give a very brief answer. 1.5. In the year 2001, what is the difference between the Imports(as % of merchandise exports) in Ireland and Imports(as % of merchandise exports) in Senegal?
Offer a terse response. -0.57. In the year 2002, what is the difference between the Imports(as % of merchandise exports) in East Asia (all income levels) and Imports(as % of merchandise exports) in Belarus?
Keep it short and to the point. 0.31. In the year 2002, what is the difference between the Imports(as % of merchandise exports) in East Asia (all income levels) and Imports(as % of merchandise exports) in Ireland?
Provide a succinct answer. 2.55. In the year 2002, what is the difference between the Imports(as % of merchandise exports) in East Asia (all income levels) and Imports(as % of merchandise exports) in Senegal?
Ensure brevity in your answer.  2.91. In the year 2002, what is the difference between the Imports(as % of merchandise exports) of Belarus and Imports(as % of merchandise exports) of Ireland?
Offer a very short reply. 2.24. In the year 2002, what is the difference between the Imports(as % of merchandise exports) in Belarus and Imports(as % of merchandise exports) in Senegal?
Give a very brief answer. 2.6. In the year 2002, what is the difference between the Imports(as % of merchandise exports) of Ireland and Imports(as % of merchandise exports) of Senegal?
Your answer should be very brief. 0.37. In the year 2003, what is the difference between the Imports(as % of merchandise exports) in East Asia (all income levels) and Imports(as % of merchandise exports) in Belarus?
Your answer should be compact. 0.41. In the year 2003, what is the difference between the Imports(as % of merchandise exports) of East Asia (all income levels) and Imports(as % of merchandise exports) of Ireland?
Ensure brevity in your answer.  2.57. In the year 2003, what is the difference between the Imports(as % of merchandise exports) of East Asia (all income levels) and Imports(as % of merchandise exports) of Senegal?
Keep it short and to the point. 1.44. In the year 2003, what is the difference between the Imports(as % of merchandise exports) of Belarus and Imports(as % of merchandise exports) of Ireland?
Keep it short and to the point. 2.15. In the year 2003, what is the difference between the Imports(as % of merchandise exports) of Belarus and Imports(as % of merchandise exports) of Senegal?
Give a very brief answer. 1.03. In the year 2003, what is the difference between the Imports(as % of merchandise exports) of Ireland and Imports(as % of merchandise exports) of Senegal?
Keep it short and to the point. -1.12. In the year 2004, what is the difference between the Imports(as % of merchandise exports) of East Asia (all income levels) and Imports(as % of merchandise exports) of Belarus?
Your response must be concise. 1.28. In the year 2004, what is the difference between the Imports(as % of merchandise exports) of East Asia (all income levels) and Imports(as % of merchandise exports) of Ireland?
Make the answer very short. 3.41. In the year 2004, what is the difference between the Imports(as % of merchandise exports) of East Asia (all income levels) and Imports(as % of merchandise exports) of Senegal?
Your answer should be compact. 2.41. In the year 2004, what is the difference between the Imports(as % of merchandise exports) of Belarus and Imports(as % of merchandise exports) of Ireland?
Make the answer very short. 2.13. In the year 2004, what is the difference between the Imports(as % of merchandise exports) of Belarus and Imports(as % of merchandise exports) of Senegal?
Offer a very short reply. 1.14. In the year 2004, what is the difference between the Imports(as % of merchandise exports) in Ireland and Imports(as % of merchandise exports) in Senegal?
Your response must be concise. -1. In the year 2005, what is the difference between the Imports(as % of merchandise exports) of East Asia (all income levels) and Imports(as % of merchandise exports) of Belarus?
Ensure brevity in your answer.  2.09. In the year 2005, what is the difference between the Imports(as % of merchandise exports) of East Asia (all income levels) and Imports(as % of merchandise exports) of Ireland?
Give a very brief answer. 3.82. In the year 2005, what is the difference between the Imports(as % of merchandise exports) in East Asia (all income levels) and Imports(as % of merchandise exports) in Senegal?
Your answer should be very brief. 3.08. In the year 2005, what is the difference between the Imports(as % of merchandise exports) in Belarus and Imports(as % of merchandise exports) in Ireland?
Make the answer very short. 1.73. In the year 2005, what is the difference between the Imports(as % of merchandise exports) in Belarus and Imports(as % of merchandise exports) in Senegal?
Provide a short and direct response. 0.99. In the year 2005, what is the difference between the Imports(as % of merchandise exports) of Ireland and Imports(as % of merchandise exports) of Senegal?
Provide a short and direct response. -0.74. In the year 2006, what is the difference between the Imports(as % of merchandise exports) of East Asia (all income levels) and Imports(as % of merchandise exports) of Belarus?
Provide a succinct answer. 2.53. In the year 2006, what is the difference between the Imports(as % of merchandise exports) in East Asia (all income levels) and Imports(as % of merchandise exports) in Ireland?
Keep it short and to the point. 4.6. In the year 2006, what is the difference between the Imports(as % of merchandise exports) in East Asia (all income levels) and Imports(as % of merchandise exports) in Senegal?
Your answer should be compact. 5.23. In the year 2006, what is the difference between the Imports(as % of merchandise exports) of Belarus and Imports(as % of merchandise exports) of Ireland?
Offer a terse response. 2.07. In the year 2006, what is the difference between the Imports(as % of merchandise exports) in Belarus and Imports(as % of merchandise exports) in Senegal?
Keep it short and to the point. 2.7. In the year 2006, what is the difference between the Imports(as % of merchandise exports) in Ireland and Imports(as % of merchandise exports) in Senegal?
Ensure brevity in your answer.  0.63. In the year 2007, what is the difference between the Imports(as % of merchandise exports) in East Asia (all income levels) and Imports(as % of merchandise exports) in Belarus?
Ensure brevity in your answer.  3.69. In the year 2007, what is the difference between the Imports(as % of merchandise exports) in East Asia (all income levels) and Imports(as % of merchandise exports) in Ireland?
Make the answer very short. 5.55. In the year 2007, what is the difference between the Imports(as % of merchandise exports) in East Asia (all income levels) and Imports(as % of merchandise exports) in Senegal?
Provide a short and direct response. 5.95. In the year 2007, what is the difference between the Imports(as % of merchandise exports) of Belarus and Imports(as % of merchandise exports) of Ireland?
Ensure brevity in your answer.  1.87. In the year 2007, what is the difference between the Imports(as % of merchandise exports) in Belarus and Imports(as % of merchandise exports) in Senegal?
Make the answer very short. 2.26. In the year 2007, what is the difference between the Imports(as % of merchandise exports) of Ireland and Imports(as % of merchandise exports) of Senegal?
Keep it short and to the point. 0.39. In the year 2008, what is the difference between the Imports(as % of merchandise exports) in East Asia (all income levels) and Imports(as % of merchandise exports) in Belarus?
Provide a short and direct response. 3.5. In the year 2008, what is the difference between the Imports(as % of merchandise exports) of East Asia (all income levels) and Imports(as % of merchandise exports) of Ireland?
Ensure brevity in your answer.  5.59. In the year 2008, what is the difference between the Imports(as % of merchandise exports) in East Asia (all income levels) and Imports(as % of merchandise exports) in Senegal?
Provide a short and direct response. 4.89. In the year 2008, what is the difference between the Imports(as % of merchandise exports) in Belarus and Imports(as % of merchandise exports) in Ireland?
Your response must be concise. 2.09. In the year 2008, what is the difference between the Imports(as % of merchandise exports) in Belarus and Imports(as % of merchandise exports) in Senegal?
Your answer should be compact. 1.39. In the year 2008, what is the difference between the Imports(as % of merchandise exports) of Ireland and Imports(as % of merchandise exports) of Senegal?
Ensure brevity in your answer.  -0.7. What is the ratio of the Imports(as % of merchandise exports) of East Asia (all income levels) in 2001 to that in 2002?
Offer a very short reply. 1.06. What is the ratio of the Imports(as % of merchandise exports) of Belarus in 2001 to that in 2002?
Offer a very short reply. 0.96. What is the ratio of the Imports(as % of merchandise exports) of Ireland in 2001 to that in 2002?
Provide a short and direct response. 1.02. What is the ratio of the Imports(as % of merchandise exports) in Senegal in 2001 to that in 2002?
Offer a very short reply. 2.01. What is the ratio of the Imports(as % of merchandise exports) in East Asia (all income levels) in 2001 to that in 2003?
Your response must be concise. 1.03. What is the ratio of the Imports(as % of merchandise exports) in Belarus in 2001 to that in 2003?
Make the answer very short. 0.96. What is the ratio of the Imports(as % of merchandise exports) of Ireland in 2001 to that in 2003?
Offer a terse response. 0.95. What is the ratio of the Imports(as % of merchandise exports) of Senegal in 2001 to that in 2003?
Make the answer very short. 0.75. What is the ratio of the Imports(as % of merchandise exports) in East Asia (all income levels) in 2001 to that in 2004?
Your answer should be compact. 0.84. What is the ratio of the Imports(as % of merchandise exports) in Belarus in 2001 to that in 2004?
Give a very brief answer. 0.94. What is the ratio of the Imports(as % of merchandise exports) in Ireland in 2001 to that in 2004?
Offer a very short reply. 0.91. What is the ratio of the Imports(as % of merchandise exports) of Senegal in 2001 to that in 2004?
Make the answer very short. 0.77. What is the ratio of the Imports(as % of merchandise exports) in East Asia (all income levels) in 2001 to that in 2005?
Provide a succinct answer. 0.78. What is the ratio of the Imports(as % of merchandise exports) of Belarus in 2001 to that in 2005?
Your answer should be compact. 1.08. What is the ratio of the Imports(as % of merchandise exports) of Ireland in 2001 to that in 2005?
Make the answer very short. 0.95. What is the ratio of the Imports(as % of merchandise exports) in Senegal in 2001 to that in 2005?
Keep it short and to the point. 0.88. What is the ratio of the Imports(as % of merchandise exports) of East Asia (all income levels) in 2001 to that in 2006?
Ensure brevity in your answer.  0.66. What is the ratio of the Imports(as % of merchandise exports) in Belarus in 2001 to that in 2006?
Ensure brevity in your answer.  0.92. What is the ratio of the Imports(as % of merchandise exports) of Ireland in 2001 to that in 2006?
Give a very brief answer. 0.83. What is the ratio of the Imports(as % of merchandise exports) of Senegal in 2001 to that in 2006?
Provide a succinct answer. 1.92. What is the ratio of the Imports(as % of merchandise exports) in East Asia (all income levels) in 2001 to that in 2007?
Keep it short and to the point. 0.56. What is the ratio of the Imports(as % of merchandise exports) of Belarus in 2001 to that in 2007?
Provide a succinct answer. 0.95. What is the ratio of the Imports(as % of merchandise exports) of Ireland in 2001 to that in 2007?
Give a very brief answer. 0.79. What is the ratio of the Imports(as % of merchandise exports) in Senegal in 2001 to that in 2007?
Provide a short and direct response. 1.45. What is the ratio of the Imports(as % of merchandise exports) of East Asia (all income levels) in 2001 to that in 2008?
Keep it short and to the point. 0.57. What is the ratio of the Imports(as % of merchandise exports) of Belarus in 2001 to that in 2008?
Ensure brevity in your answer.  0.92. What is the ratio of the Imports(as % of merchandise exports) of Ireland in 2001 to that in 2008?
Your answer should be very brief. 0.83. What is the ratio of the Imports(as % of merchandise exports) in Senegal in 2001 to that in 2008?
Make the answer very short. 0.82. What is the ratio of the Imports(as % of merchandise exports) in East Asia (all income levels) in 2002 to that in 2003?
Offer a very short reply. 0.97. What is the ratio of the Imports(as % of merchandise exports) in Belarus in 2002 to that in 2003?
Ensure brevity in your answer.  1. What is the ratio of the Imports(as % of merchandise exports) of Ireland in 2002 to that in 2003?
Provide a succinct answer. 0.93. What is the ratio of the Imports(as % of merchandise exports) in Senegal in 2002 to that in 2003?
Keep it short and to the point. 0.38. What is the ratio of the Imports(as % of merchandise exports) in East Asia (all income levels) in 2002 to that in 2004?
Your response must be concise. 0.79. What is the ratio of the Imports(as % of merchandise exports) in Belarus in 2002 to that in 2004?
Provide a succinct answer. 0.98. What is the ratio of the Imports(as % of merchandise exports) in Ireland in 2002 to that in 2004?
Keep it short and to the point. 0.89. What is the ratio of the Imports(as % of merchandise exports) of Senegal in 2002 to that in 2004?
Your answer should be compact. 0.39. What is the ratio of the Imports(as % of merchandise exports) in East Asia (all income levels) in 2002 to that in 2005?
Give a very brief answer. 0.74. What is the ratio of the Imports(as % of merchandise exports) in Belarus in 2002 to that in 2005?
Your answer should be very brief. 1.13. What is the ratio of the Imports(as % of merchandise exports) in Ireland in 2002 to that in 2005?
Make the answer very short. 0.93. What is the ratio of the Imports(as % of merchandise exports) of Senegal in 2002 to that in 2005?
Keep it short and to the point. 0.44. What is the ratio of the Imports(as % of merchandise exports) of East Asia (all income levels) in 2002 to that in 2006?
Your answer should be compact. 0.62. What is the ratio of the Imports(as % of merchandise exports) in Belarus in 2002 to that in 2006?
Give a very brief answer. 0.96. What is the ratio of the Imports(as % of merchandise exports) of Ireland in 2002 to that in 2006?
Offer a terse response. 0.81. What is the ratio of the Imports(as % of merchandise exports) of Senegal in 2002 to that in 2006?
Make the answer very short. 0.96. What is the ratio of the Imports(as % of merchandise exports) in East Asia (all income levels) in 2002 to that in 2007?
Offer a very short reply. 0.53. What is the ratio of the Imports(as % of merchandise exports) in Belarus in 2002 to that in 2007?
Provide a short and direct response. 0.99. What is the ratio of the Imports(as % of merchandise exports) in Ireland in 2002 to that in 2007?
Your answer should be compact. 0.77. What is the ratio of the Imports(as % of merchandise exports) of Senegal in 2002 to that in 2007?
Give a very brief answer. 0.72. What is the ratio of the Imports(as % of merchandise exports) in East Asia (all income levels) in 2002 to that in 2008?
Make the answer very short. 0.54. What is the ratio of the Imports(as % of merchandise exports) of Belarus in 2002 to that in 2008?
Ensure brevity in your answer.  0.96. What is the ratio of the Imports(as % of merchandise exports) of Ireland in 2002 to that in 2008?
Keep it short and to the point. 0.81. What is the ratio of the Imports(as % of merchandise exports) in Senegal in 2002 to that in 2008?
Give a very brief answer. 0.41. What is the ratio of the Imports(as % of merchandise exports) in East Asia (all income levels) in 2003 to that in 2004?
Keep it short and to the point. 0.81. What is the ratio of the Imports(as % of merchandise exports) in Belarus in 2003 to that in 2004?
Your response must be concise. 0.99. What is the ratio of the Imports(as % of merchandise exports) of Ireland in 2003 to that in 2004?
Your answer should be compact. 0.96. What is the ratio of the Imports(as % of merchandise exports) in Senegal in 2003 to that in 2004?
Your answer should be compact. 1.03. What is the ratio of the Imports(as % of merchandise exports) of East Asia (all income levels) in 2003 to that in 2005?
Ensure brevity in your answer.  0.76. What is the ratio of the Imports(as % of merchandise exports) of Belarus in 2003 to that in 2005?
Ensure brevity in your answer.  1.13. What is the ratio of the Imports(as % of merchandise exports) in Senegal in 2003 to that in 2005?
Provide a short and direct response. 1.17. What is the ratio of the Imports(as % of merchandise exports) of East Asia (all income levels) in 2003 to that in 2006?
Make the answer very short. 0.64. What is the ratio of the Imports(as % of merchandise exports) in Belarus in 2003 to that in 2006?
Your answer should be compact. 0.96. What is the ratio of the Imports(as % of merchandise exports) of Ireland in 2003 to that in 2006?
Provide a succinct answer. 0.87. What is the ratio of the Imports(as % of merchandise exports) of Senegal in 2003 to that in 2006?
Give a very brief answer. 2.54. What is the ratio of the Imports(as % of merchandise exports) in East Asia (all income levels) in 2003 to that in 2007?
Ensure brevity in your answer.  0.55. What is the ratio of the Imports(as % of merchandise exports) in Belarus in 2003 to that in 2007?
Your answer should be very brief. 1. What is the ratio of the Imports(as % of merchandise exports) in Ireland in 2003 to that in 2007?
Provide a succinct answer. 0.83. What is the ratio of the Imports(as % of merchandise exports) of Senegal in 2003 to that in 2007?
Provide a succinct answer. 1.92. What is the ratio of the Imports(as % of merchandise exports) of East Asia (all income levels) in 2003 to that in 2008?
Offer a terse response. 0.55. What is the ratio of the Imports(as % of merchandise exports) in Ireland in 2003 to that in 2008?
Ensure brevity in your answer.  0.87. What is the ratio of the Imports(as % of merchandise exports) in Senegal in 2003 to that in 2008?
Your answer should be compact. 1.09. What is the ratio of the Imports(as % of merchandise exports) of East Asia (all income levels) in 2004 to that in 2005?
Give a very brief answer. 0.93. What is the ratio of the Imports(as % of merchandise exports) in Belarus in 2004 to that in 2005?
Your answer should be compact. 1.15. What is the ratio of the Imports(as % of merchandise exports) in Ireland in 2004 to that in 2005?
Your response must be concise. 1.04. What is the ratio of the Imports(as % of merchandise exports) of Senegal in 2004 to that in 2005?
Your answer should be compact. 1.14. What is the ratio of the Imports(as % of merchandise exports) of East Asia (all income levels) in 2004 to that in 2006?
Keep it short and to the point. 0.78. What is the ratio of the Imports(as % of merchandise exports) of Belarus in 2004 to that in 2006?
Keep it short and to the point. 0.98. What is the ratio of the Imports(as % of merchandise exports) in Ireland in 2004 to that in 2006?
Provide a short and direct response. 0.91. What is the ratio of the Imports(as % of merchandise exports) of Senegal in 2004 to that in 2006?
Make the answer very short. 2.48. What is the ratio of the Imports(as % of merchandise exports) of East Asia (all income levels) in 2004 to that in 2007?
Keep it short and to the point. 0.67. What is the ratio of the Imports(as % of merchandise exports) of Belarus in 2004 to that in 2007?
Provide a short and direct response. 1.01. What is the ratio of the Imports(as % of merchandise exports) in Ireland in 2004 to that in 2007?
Offer a very short reply. 0.86. What is the ratio of the Imports(as % of merchandise exports) of Senegal in 2004 to that in 2007?
Your response must be concise. 1.87. What is the ratio of the Imports(as % of merchandise exports) in East Asia (all income levels) in 2004 to that in 2008?
Provide a short and direct response. 0.68. What is the ratio of the Imports(as % of merchandise exports) in Belarus in 2004 to that in 2008?
Your response must be concise. 0.97. What is the ratio of the Imports(as % of merchandise exports) in Ireland in 2004 to that in 2008?
Your answer should be compact. 0.91. What is the ratio of the Imports(as % of merchandise exports) in Senegal in 2004 to that in 2008?
Make the answer very short. 1.06. What is the ratio of the Imports(as % of merchandise exports) of East Asia (all income levels) in 2005 to that in 2006?
Give a very brief answer. 0.84. What is the ratio of the Imports(as % of merchandise exports) in Belarus in 2005 to that in 2006?
Provide a short and direct response. 0.85. What is the ratio of the Imports(as % of merchandise exports) of Ireland in 2005 to that in 2006?
Provide a short and direct response. 0.88. What is the ratio of the Imports(as % of merchandise exports) of Senegal in 2005 to that in 2006?
Give a very brief answer. 2.17. What is the ratio of the Imports(as % of merchandise exports) of East Asia (all income levels) in 2005 to that in 2007?
Give a very brief answer. 0.72. What is the ratio of the Imports(as % of merchandise exports) of Belarus in 2005 to that in 2007?
Your answer should be compact. 0.88. What is the ratio of the Imports(as % of merchandise exports) of Ireland in 2005 to that in 2007?
Give a very brief answer. 0.83. What is the ratio of the Imports(as % of merchandise exports) of Senegal in 2005 to that in 2007?
Make the answer very short. 1.63. What is the ratio of the Imports(as % of merchandise exports) of East Asia (all income levels) in 2005 to that in 2008?
Offer a terse response. 0.73. What is the ratio of the Imports(as % of merchandise exports) of Belarus in 2005 to that in 2008?
Make the answer very short. 0.85. What is the ratio of the Imports(as % of merchandise exports) of Ireland in 2005 to that in 2008?
Your response must be concise. 0.87. What is the ratio of the Imports(as % of merchandise exports) of Senegal in 2005 to that in 2008?
Offer a very short reply. 0.93. What is the ratio of the Imports(as % of merchandise exports) in East Asia (all income levels) in 2006 to that in 2007?
Your response must be concise. 0.86. What is the ratio of the Imports(as % of merchandise exports) of Belarus in 2006 to that in 2007?
Your response must be concise. 1.03. What is the ratio of the Imports(as % of merchandise exports) in Ireland in 2006 to that in 2007?
Give a very brief answer. 0.95. What is the ratio of the Imports(as % of merchandise exports) in Senegal in 2006 to that in 2007?
Give a very brief answer. 0.75. What is the ratio of the Imports(as % of merchandise exports) of East Asia (all income levels) in 2006 to that in 2008?
Your answer should be compact. 0.86. What is the ratio of the Imports(as % of merchandise exports) in Ireland in 2006 to that in 2008?
Your answer should be very brief. 1. What is the ratio of the Imports(as % of merchandise exports) of Senegal in 2006 to that in 2008?
Offer a terse response. 0.43. What is the ratio of the Imports(as % of merchandise exports) of Belarus in 2007 to that in 2008?
Your answer should be compact. 0.96. What is the ratio of the Imports(as % of merchandise exports) in Ireland in 2007 to that in 2008?
Make the answer very short. 1.05. What is the ratio of the Imports(as % of merchandise exports) of Senegal in 2007 to that in 2008?
Your response must be concise. 0.57. What is the difference between the highest and the second highest Imports(as % of merchandise exports) of East Asia (all income levels)?
Provide a short and direct response. 0.05. What is the difference between the highest and the second highest Imports(as % of merchandise exports) of Belarus?
Provide a succinct answer. 0.02. What is the difference between the highest and the second highest Imports(as % of merchandise exports) of Ireland?
Ensure brevity in your answer.  0.08. What is the difference between the highest and the second highest Imports(as % of merchandise exports) of Senegal?
Your answer should be very brief. 0.06. What is the difference between the highest and the lowest Imports(as % of merchandise exports) in East Asia (all income levels)?
Keep it short and to the point. 3.4. What is the difference between the highest and the lowest Imports(as % of merchandise exports) of Belarus?
Offer a very short reply. 0.57. What is the difference between the highest and the lowest Imports(as % of merchandise exports) of Ireland?
Your response must be concise. 0.4. What is the difference between the highest and the lowest Imports(as % of merchandise exports) in Senegal?
Offer a terse response. 1.59. 